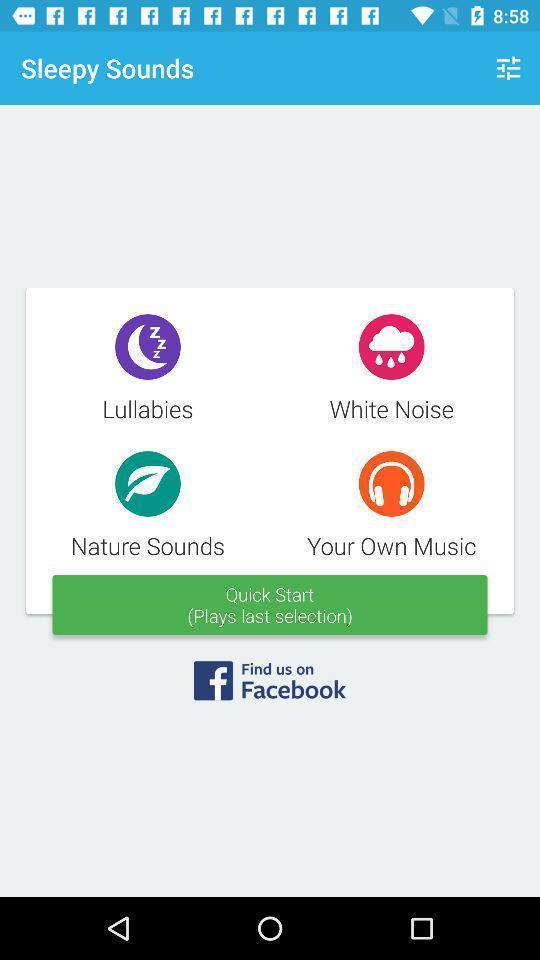What details can you identify in this image? Pop-up for play music with selected sound app. 